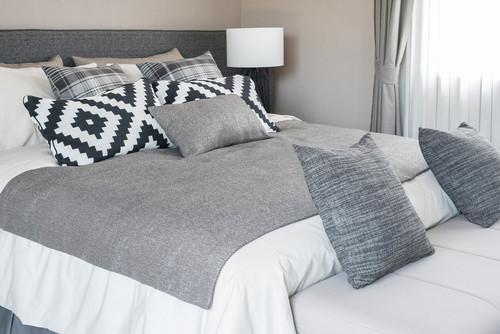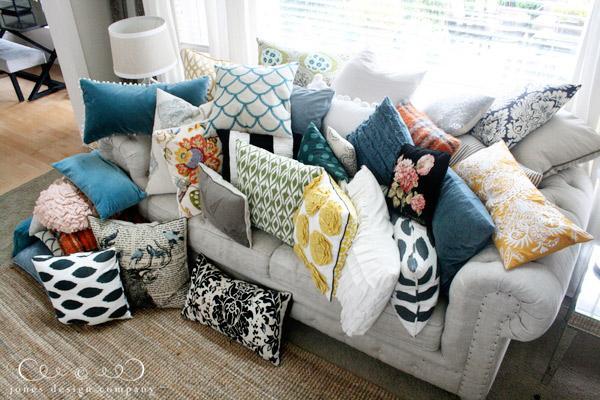The first image is the image on the left, the second image is the image on the right. Considering the images on both sides, is "There is at least one human lying on a bed." valid? Answer yes or no. No. The first image is the image on the left, the second image is the image on the right. Analyze the images presented: Is the assertion "One image contains at least six full-size all white bed pillows." valid? Answer yes or no. No. 